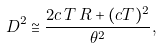Convert formula to latex. <formula><loc_0><loc_0><loc_500><loc_500>D ^ { 2 } \cong \frac { 2 c \, T \, R + ( c T ) ^ { 2 } } { \theta ^ { 2 } } ,</formula> 